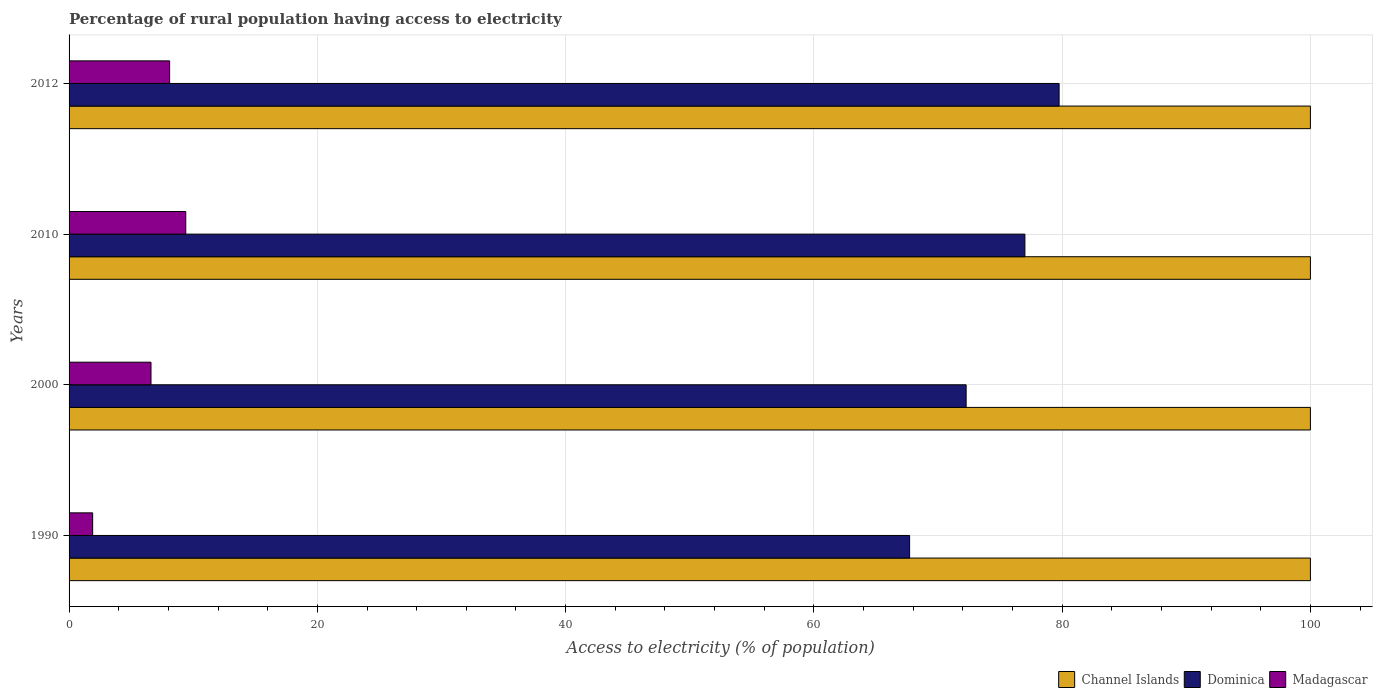How many different coloured bars are there?
Make the answer very short. 3. How many groups of bars are there?
Offer a terse response. 4. Are the number of bars per tick equal to the number of legend labels?
Make the answer very short. Yes. Are the number of bars on each tick of the Y-axis equal?
Offer a terse response. Yes. How many bars are there on the 1st tick from the top?
Ensure brevity in your answer.  3. How many bars are there on the 2nd tick from the bottom?
Give a very brief answer. 3. What is the label of the 1st group of bars from the top?
Provide a short and direct response. 2012. In how many cases, is the number of bars for a given year not equal to the number of legend labels?
Provide a short and direct response. 0. What is the percentage of rural population having access to electricity in Channel Islands in 2012?
Your answer should be very brief. 100. Across all years, what is the maximum percentage of rural population having access to electricity in Channel Islands?
Offer a very short reply. 100. Across all years, what is the minimum percentage of rural population having access to electricity in Channel Islands?
Ensure brevity in your answer.  100. In which year was the percentage of rural population having access to electricity in Channel Islands maximum?
Offer a very short reply. 1990. In which year was the percentage of rural population having access to electricity in Madagascar minimum?
Keep it short and to the point. 1990. What is the total percentage of rural population having access to electricity in Madagascar in the graph?
Make the answer very short. 26. What is the difference between the percentage of rural population having access to electricity in Madagascar in 2010 and the percentage of rural population having access to electricity in Channel Islands in 2000?
Your response must be concise. -90.6. What is the average percentage of rural population having access to electricity in Dominica per year?
Provide a succinct answer. 74.18. In the year 2012, what is the difference between the percentage of rural population having access to electricity in Channel Islands and percentage of rural population having access to electricity in Madagascar?
Provide a succinct answer. 91.9. In how many years, is the percentage of rural population having access to electricity in Channel Islands greater than 64 %?
Keep it short and to the point. 4. What is the ratio of the percentage of rural population having access to electricity in Dominica in 2000 to that in 2010?
Give a very brief answer. 0.94. Is the difference between the percentage of rural population having access to electricity in Channel Islands in 1990 and 2000 greater than the difference between the percentage of rural population having access to electricity in Madagascar in 1990 and 2000?
Make the answer very short. Yes. What is the difference between the highest and the second highest percentage of rural population having access to electricity in Dominica?
Ensure brevity in your answer.  2.75. What is the difference between the highest and the lowest percentage of rural population having access to electricity in Channel Islands?
Keep it short and to the point. 0. In how many years, is the percentage of rural population having access to electricity in Channel Islands greater than the average percentage of rural population having access to electricity in Channel Islands taken over all years?
Ensure brevity in your answer.  0. What does the 1st bar from the top in 1990 represents?
Provide a short and direct response. Madagascar. What does the 1st bar from the bottom in 1990 represents?
Offer a very short reply. Channel Islands. How many bars are there?
Offer a very short reply. 12. What is the difference between two consecutive major ticks on the X-axis?
Keep it short and to the point. 20. Are the values on the major ticks of X-axis written in scientific E-notation?
Give a very brief answer. No. Does the graph contain any zero values?
Your response must be concise. No. Does the graph contain grids?
Make the answer very short. Yes. How many legend labels are there?
Your answer should be very brief. 3. What is the title of the graph?
Ensure brevity in your answer.  Percentage of rural population having access to electricity. What is the label or title of the X-axis?
Your answer should be compact. Access to electricity (% of population). What is the label or title of the Y-axis?
Make the answer very short. Years. What is the Access to electricity (% of population) of Dominica in 1990?
Provide a short and direct response. 67.71. What is the Access to electricity (% of population) of Madagascar in 1990?
Keep it short and to the point. 1.9. What is the Access to electricity (% of population) of Dominica in 2000?
Provide a succinct answer. 72.27. What is the Access to electricity (% of population) in Madagascar in 2000?
Your response must be concise. 6.6. What is the Access to electricity (% of population) in Channel Islands in 2010?
Offer a very short reply. 100. What is the Access to electricity (% of population) in Dominica in 2010?
Provide a succinct answer. 77. What is the Access to electricity (% of population) of Madagascar in 2010?
Your answer should be compact. 9.4. What is the Access to electricity (% of population) in Dominica in 2012?
Provide a succinct answer. 79.75. Across all years, what is the maximum Access to electricity (% of population) in Channel Islands?
Offer a very short reply. 100. Across all years, what is the maximum Access to electricity (% of population) in Dominica?
Provide a short and direct response. 79.75. Across all years, what is the minimum Access to electricity (% of population) of Channel Islands?
Make the answer very short. 100. Across all years, what is the minimum Access to electricity (% of population) in Dominica?
Provide a succinct answer. 67.71. What is the total Access to electricity (% of population) of Dominica in the graph?
Your answer should be compact. 296.73. What is the difference between the Access to electricity (% of population) of Channel Islands in 1990 and that in 2000?
Give a very brief answer. 0. What is the difference between the Access to electricity (% of population) in Dominica in 1990 and that in 2000?
Make the answer very short. -4.55. What is the difference between the Access to electricity (% of population) in Madagascar in 1990 and that in 2000?
Ensure brevity in your answer.  -4.7. What is the difference between the Access to electricity (% of population) of Channel Islands in 1990 and that in 2010?
Ensure brevity in your answer.  0. What is the difference between the Access to electricity (% of population) in Dominica in 1990 and that in 2010?
Your answer should be very brief. -9.29. What is the difference between the Access to electricity (% of population) of Dominica in 1990 and that in 2012?
Give a very brief answer. -12.04. What is the difference between the Access to electricity (% of population) in Madagascar in 1990 and that in 2012?
Offer a very short reply. -6.2. What is the difference between the Access to electricity (% of population) of Dominica in 2000 and that in 2010?
Keep it short and to the point. -4.74. What is the difference between the Access to electricity (% of population) of Dominica in 2000 and that in 2012?
Your answer should be compact. -7.49. What is the difference between the Access to electricity (% of population) in Madagascar in 2000 and that in 2012?
Offer a very short reply. -1.5. What is the difference between the Access to electricity (% of population) of Channel Islands in 2010 and that in 2012?
Keep it short and to the point. 0. What is the difference between the Access to electricity (% of population) of Dominica in 2010 and that in 2012?
Your response must be concise. -2.75. What is the difference between the Access to electricity (% of population) in Madagascar in 2010 and that in 2012?
Make the answer very short. 1.3. What is the difference between the Access to electricity (% of population) in Channel Islands in 1990 and the Access to electricity (% of population) in Dominica in 2000?
Your answer should be very brief. 27.73. What is the difference between the Access to electricity (% of population) in Channel Islands in 1990 and the Access to electricity (% of population) in Madagascar in 2000?
Your answer should be very brief. 93.4. What is the difference between the Access to electricity (% of population) of Dominica in 1990 and the Access to electricity (% of population) of Madagascar in 2000?
Keep it short and to the point. 61.11. What is the difference between the Access to electricity (% of population) in Channel Islands in 1990 and the Access to electricity (% of population) in Madagascar in 2010?
Your response must be concise. 90.6. What is the difference between the Access to electricity (% of population) in Dominica in 1990 and the Access to electricity (% of population) in Madagascar in 2010?
Provide a succinct answer. 58.31. What is the difference between the Access to electricity (% of population) of Channel Islands in 1990 and the Access to electricity (% of population) of Dominica in 2012?
Make the answer very short. 20.25. What is the difference between the Access to electricity (% of population) of Channel Islands in 1990 and the Access to electricity (% of population) of Madagascar in 2012?
Offer a terse response. 91.9. What is the difference between the Access to electricity (% of population) in Dominica in 1990 and the Access to electricity (% of population) in Madagascar in 2012?
Your answer should be compact. 59.61. What is the difference between the Access to electricity (% of population) of Channel Islands in 2000 and the Access to electricity (% of population) of Dominica in 2010?
Provide a succinct answer. 23. What is the difference between the Access to electricity (% of population) of Channel Islands in 2000 and the Access to electricity (% of population) of Madagascar in 2010?
Provide a succinct answer. 90.6. What is the difference between the Access to electricity (% of population) of Dominica in 2000 and the Access to electricity (% of population) of Madagascar in 2010?
Ensure brevity in your answer.  62.87. What is the difference between the Access to electricity (% of population) in Channel Islands in 2000 and the Access to electricity (% of population) in Dominica in 2012?
Offer a very short reply. 20.25. What is the difference between the Access to electricity (% of population) of Channel Islands in 2000 and the Access to electricity (% of population) of Madagascar in 2012?
Give a very brief answer. 91.9. What is the difference between the Access to electricity (% of population) in Dominica in 2000 and the Access to electricity (% of population) in Madagascar in 2012?
Make the answer very short. 64.17. What is the difference between the Access to electricity (% of population) of Channel Islands in 2010 and the Access to electricity (% of population) of Dominica in 2012?
Provide a succinct answer. 20.25. What is the difference between the Access to electricity (% of population) in Channel Islands in 2010 and the Access to electricity (% of population) in Madagascar in 2012?
Your answer should be compact. 91.9. What is the difference between the Access to electricity (% of population) in Dominica in 2010 and the Access to electricity (% of population) in Madagascar in 2012?
Offer a terse response. 68.9. What is the average Access to electricity (% of population) of Channel Islands per year?
Your answer should be compact. 100. What is the average Access to electricity (% of population) in Dominica per year?
Your answer should be very brief. 74.18. In the year 1990, what is the difference between the Access to electricity (% of population) of Channel Islands and Access to electricity (% of population) of Dominica?
Ensure brevity in your answer.  32.29. In the year 1990, what is the difference between the Access to electricity (% of population) in Channel Islands and Access to electricity (% of population) in Madagascar?
Ensure brevity in your answer.  98.1. In the year 1990, what is the difference between the Access to electricity (% of population) in Dominica and Access to electricity (% of population) in Madagascar?
Your answer should be very brief. 65.81. In the year 2000, what is the difference between the Access to electricity (% of population) of Channel Islands and Access to electricity (% of population) of Dominica?
Provide a short and direct response. 27.73. In the year 2000, what is the difference between the Access to electricity (% of population) in Channel Islands and Access to electricity (% of population) in Madagascar?
Provide a short and direct response. 93.4. In the year 2000, what is the difference between the Access to electricity (% of population) in Dominica and Access to electricity (% of population) in Madagascar?
Keep it short and to the point. 65.67. In the year 2010, what is the difference between the Access to electricity (% of population) of Channel Islands and Access to electricity (% of population) of Dominica?
Your response must be concise. 23. In the year 2010, what is the difference between the Access to electricity (% of population) of Channel Islands and Access to electricity (% of population) of Madagascar?
Make the answer very short. 90.6. In the year 2010, what is the difference between the Access to electricity (% of population) of Dominica and Access to electricity (% of population) of Madagascar?
Your answer should be compact. 67.6. In the year 2012, what is the difference between the Access to electricity (% of population) of Channel Islands and Access to electricity (% of population) of Dominica?
Your answer should be compact. 20.25. In the year 2012, what is the difference between the Access to electricity (% of population) of Channel Islands and Access to electricity (% of population) of Madagascar?
Offer a terse response. 91.9. In the year 2012, what is the difference between the Access to electricity (% of population) of Dominica and Access to electricity (% of population) of Madagascar?
Provide a short and direct response. 71.65. What is the ratio of the Access to electricity (% of population) of Channel Islands in 1990 to that in 2000?
Provide a short and direct response. 1. What is the ratio of the Access to electricity (% of population) of Dominica in 1990 to that in 2000?
Your answer should be very brief. 0.94. What is the ratio of the Access to electricity (% of population) in Madagascar in 1990 to that in 2000?
Provide a short and direct response. 0.29. What is the ratio of the Access to electricity (% of population) of Channel Islands in 1990 to that in 2010?
Offer a terse response. 1. What is the ratio of the Access to electricity (% of population) of Dominica in 1990 to that in 2010?
Your answer should be very brief. 0.88. What is the ratio of the Access to electricity (% of population) of Madagascar in 1990 to that in 2010?
Offer a terse response. 0.2. What is the ratio of the Access to electricity (% of population) in Channel Islands in 1990 to that in 2012?
Give a very brief answer. 1. What is the ratio of the Access to electricity (% of population) in Dominica in 1990 to that in 2012?
Provide a succinct answer. 0.85. What is the ratio of the Access to electricity (% of population) of Madagascar in 1990 to that in 2012?
Your response must be concise. 0.23. What is the ratio of the Access to electricity (% of population) of Channel Islands in 2000 to that in 2010?
Offer a terse response. 1. What is the ratio of the Access to electricity (% of population) in Dominica in 2000 to that in 2010?
Your answer should be very brief. 0.94. What is the ratio of the Access to electricity (% of population) of Madagascar in 2000 to that in 2010?
Your response must be concise. 0.7. What is the ratio of the Access to electricity (% of population) in Dominica in 2000 to that in 2012?
Provide a short and direct response. 0.91. What is the ratio of the Access to electricity (% of population) in Madagascar in 2000 to that in 2012?
Give a very brief answer. 0.81. What is the ratio of the Access to electricity (% of population) of Dominica in 2010 to that in 2012?
Offer a terse response. 0.97. What is the ratio of the Access to electricity (% of population) in Madagascar in 2010 to that in 2012?
Provide a succinct answer. 1.16. What is the difference between the highest and the second highest Access to electricity (% of population) in Channel Islands?
Offer a very short reply. 0. What is the difference between the highest and the second highest Access to electricity (% of population) of Dominica?
Your response must be concise. 2.75. What is the difference between the highest and the second highest Access to electricity (% of population) of Madagascar?
Your answer should be very brief. 1.3. What is the difference between the highest and the lowest Access to electricity (% of population) in Channel Islands?
Provide a succinct answer. 0. What is the difference between the highest and the lowest Access to electricity (% of population) of Dominica?
Keep it short and to the point. 12.04. 